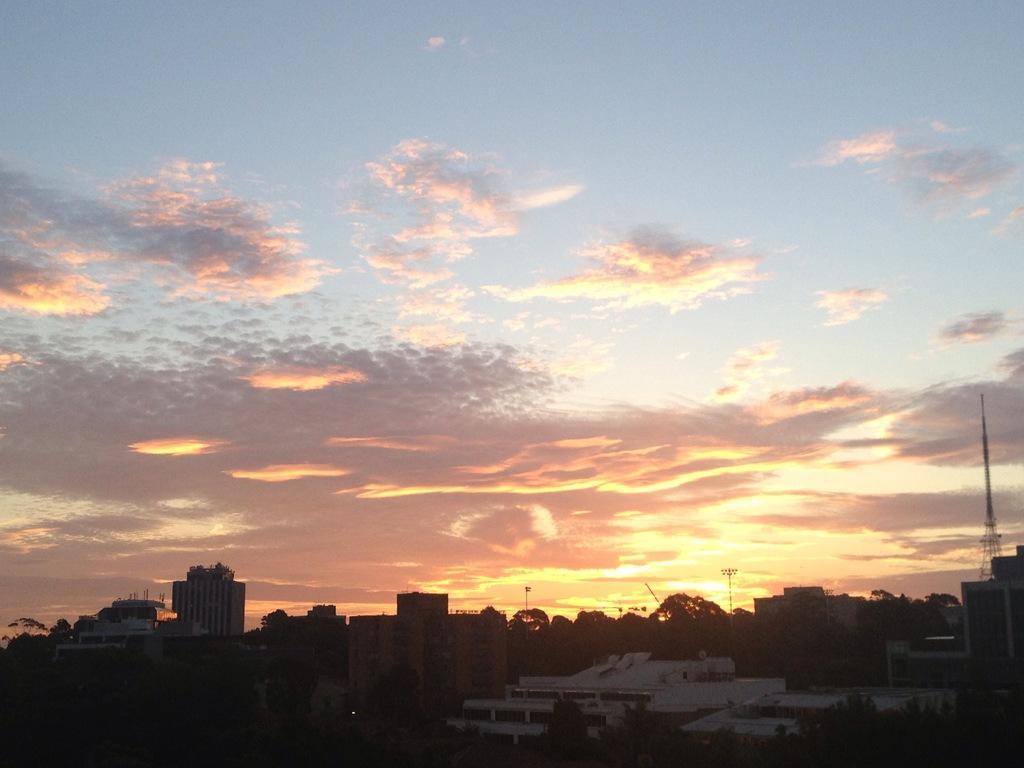Please provide a concise description of this image. In this image at the bottom there are some buildings, houses, poles, lights and also there is one tower. On the top of the image there is sky. 